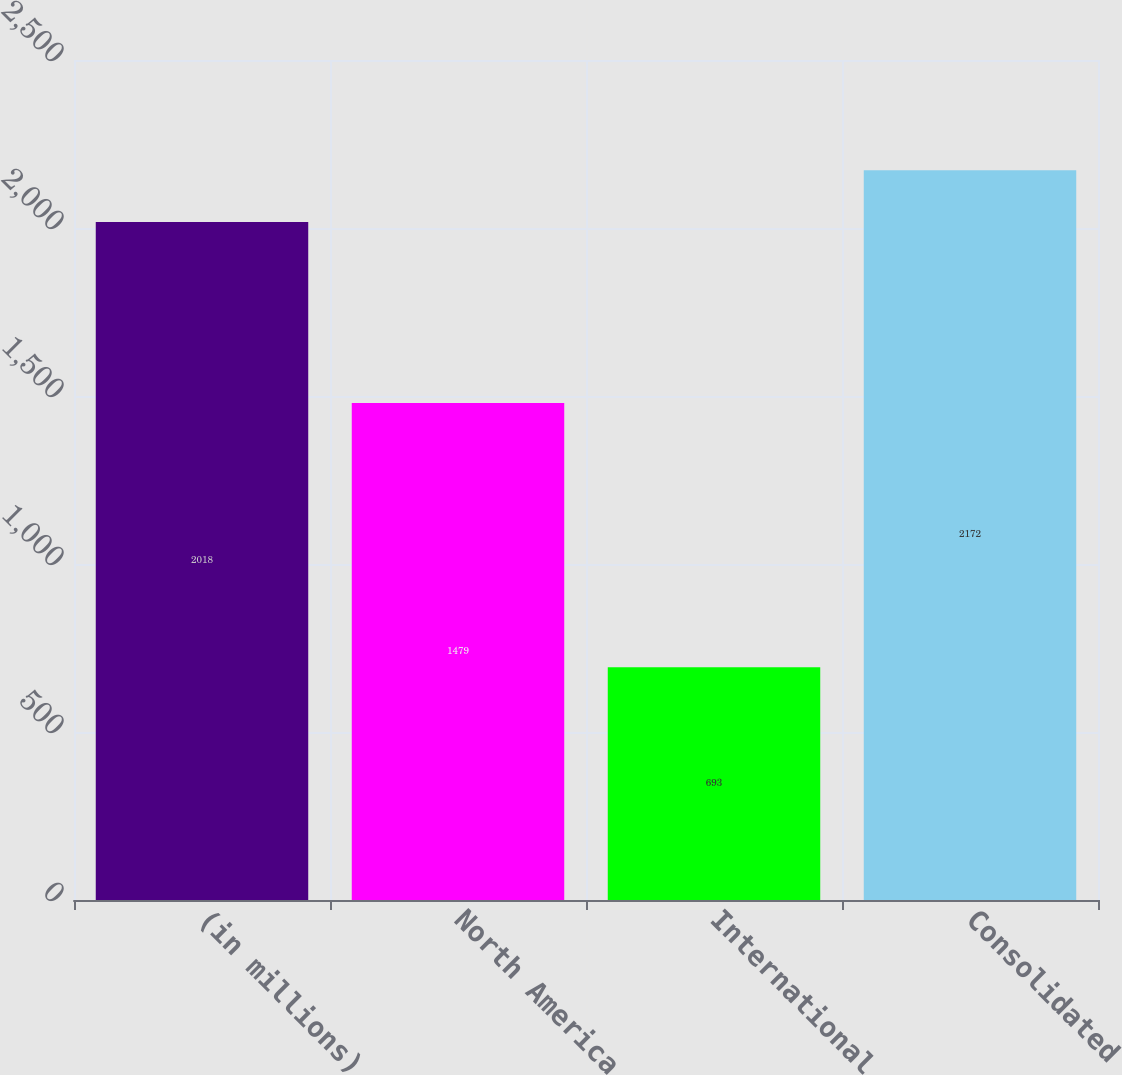Convert chart. <chart><loc_0><loc_0><loc_500><loc_500><bar_chart><fcel>(in millions)<fcel>North America<fcel>International<fcel>Consolidated<nl><fcel>2018<fcel>1479<fcel>693<fcel>2172<nl></chart> 